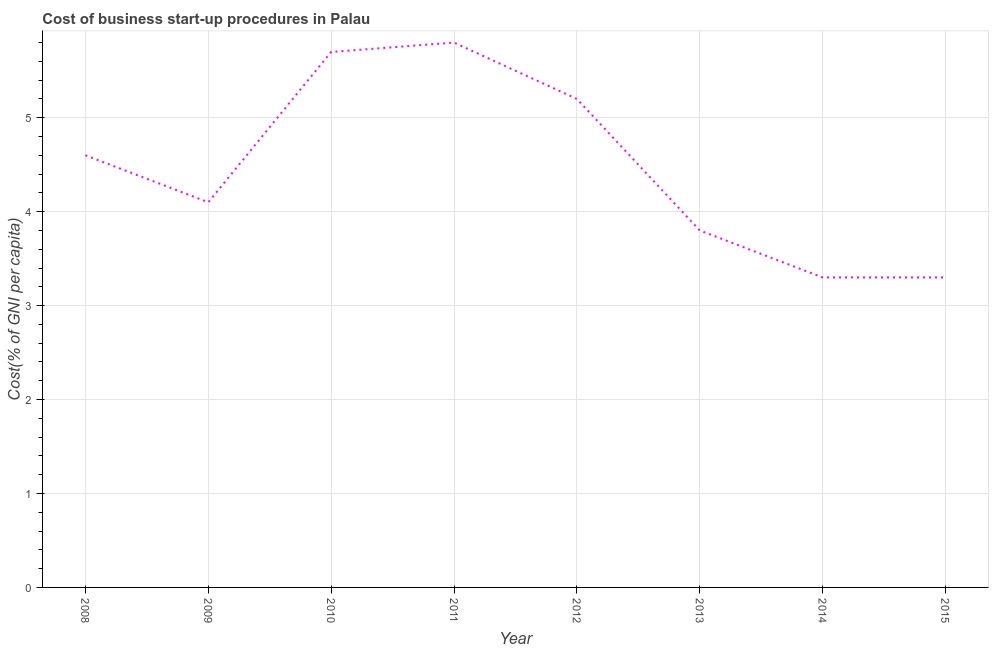In which year was the cost of business startup procedures minimum?
Ensure brevity in your answer.  2014. What is the sum of the cost of business startup procedures?
Keep it short and to the point. 35.8. What is the difference between the cost of business startup procedures in 2008 and 2014?
Make the answer very short. 1.3. What is the average cost of business startup procedures per year?
Your response must be concise. 4.47. What is the median cost of business startup procedures?
Your answer should be compact. 4.35. In how many years, is the cost of business startup procedures greater than 2 %?
Make the answer very short. 8. Do a majority of the years between 2013 and 2009 (inclusive) have cost of business startup procedures greater than 5.6 %?
Your answer should be very brief. Yes. What is the ratio of the cost of business startup procedures in 2008 to that in 2012?
Ensure brevity in your answer.  0.88. Is the cost of business startup procedures in 2009 less than that in 2012?
Ensure brevity in your answer.  Yes. Is the difference between the cost of business startup procedures in 2011 and 2015 greater than the difference between any two years?
Offer a terse response. Yes. What is the difference between the highest and the second highest cost of business startup procedures?
Give a very brief answer. 0.1. Is the sum of the cost of business startup procedures in 2012 and 2015 greater than the maximum cost of business startup procedures across all years?
Your answer should be compact. Yes. In how many years, is the cost of business startup procedures greater than the average cost of business startup procedures taken over all years?
Make the answer very short. 4. How many lines are there?
Your answer should be compact. 1. What is the title of the graph?
Offer a terse response. Cost of business start-up procedures in Palau. What is the label or title of the Y-axis?
Your response must be concise. Cost(% of GNI per capita). What is the Cost(% of GNI per capita) of 2008?
Ensure brevity in your answer.  4.6. What is the Cost(% of GNI per capita) of 2012?
Your answer should be compact. 5.2. What is the difference between the Cost(% of GNI per capita) in 2008 and 2010?
Your answer should be very brief. -1.1. What is the difference between the Cost(% of GNI per capita) in 2008 and 2011?
Your answer should be compact. -1.2. What is the difference between the Cost(% of GNI per capita) in 2008 and 2012?
Keep it short and to the point. -0.6. What is the difference between the Cost(% of GNI per capita) in 2008 and 2015?
Provide a succinct answer. 1.3. What is the difference between the Cost(% of GNI per capita) in 2009 and 2010?
Provide a succinct answer. -1.6. What is the difference between the Cost(% of GNI per capita) in 2009 and 2011?
Keep it short and to the point. -1.7. What is the difference between the Cost(% of GNI per capita) in 2009 and 2015?
Your answer should be compact. 0.8. What is the difference between the Cost(% of GNI per capita) in 2010 and 2014?
Offer a very short reply. 2.4. What is the difference between the Cost(% of GNI per capita) in 2011 and 2012?
Offer a very short reply. 0.6. What is the difference between the Cost(% of GNI per capita) in 2011 and 2013?
Provide a succinct answer. 2. What is the difference between the Cost(% of GNI per capita) in 2011 and 2014?
Provide a succinct answer. 2.5. What is the difference between the Cost(% of GNI per capita) in 2011 and 2015?
Offer a very short reply. 2.5. What is the difference between the Cost(% of GNI per capita) in 2012 and 2015?
Provide a succinct answer. 1.9. What is the difference between the Cost(% of GNI per capita) in 2013 and 2014?
Your answer should be compact. 0.5. What is the difference between the Cost(% of GNI per capita) in 2013 and 2015?
Offer a very short reply. 0.5. What is the ratio of the Cost(% of GNI per capita) in 2008 to that in 2009?
Provide a short and direct response. 1.12. What is the ratio of the Cost(% of GNI per capita) in 2008 to that in 2010?
Give a very brief answer. 0.81. What is the ratio of the Cost(% of GNI per capita) in 2008 to that in 2011?
Provide a succinct answer. 0.79. What is the ratio of the Cost(% of GNI per capita) in 2008 to that in 2012?
Offer a terse response. 0.89. What is the ratio of the Cost(% of GNI per capita) in 2008 to that in 2013?
Keep it short and to the point. 1.21. What is the ratio of the Cost(% of GNI per capita) in 2008 to that in 2014?
Make the answer very short. 1.39. What is the ratio of the Cost(% of GNI per capita) in 2008 to that in 2015?
Ensure brevity in your answer.  1.39. What is the ratio of the Cost(% of GNI per capita) in 2009 to that in 2010?
Give a very brief answer. 0.72. What is the ratio of the Cost(% of GNI per capita) in 2009 to that in 2011?
Provide a succinct answer. 0.71. What is the ratio of the Cost(% of GNI per capita) in 2009 to that in 2012?
Make the answer very short. 0.79. What is the ratio of the Cost(% of GNI per capita) in 2009 to that in 2013?
Offer a very short reply. 1.08. What is the ratio of the Cost(% of GNI per capita) in 2009 to that in 2014?
Your answer should be compact. 1.24. What is the ratio of the Cost(% of GNI per capita) in 2009 to that in 2015?
Provide a succinct answer. 1.24. What is the ratio of the Cost(% of GNI per capita) in 2010 to that in 2012?
Ensure brevity in your answer.  1.1. What is the ratio of the Cost(% of GNI per capita) in 2010 to that in 2014?
Provide a short and direct response. 1.73. What is the ratio of the Cost(% of GNI per capita) in 2010 to that in 2015?
Make the answer very short. 1.73. What is the ratio of the Cost(% of GNI per capita) in 2011 to that in 2012?
Provide a short and direct response. 1.11. What is the ratio of the Cost(% of GNI per capita) in 2011 to that in 2013?
Keep it short and to the point. 1.53. What is the ratio of the Cost(% of GNI per capita) in 2011 to that in 2014?
Provide a succinct answer. 1.76. What is the ratio of the Cost(% of GNI per capita) in 2011 to that in 2015?
Offer a very short reply. 1.76. What is the ratio of the Cost(% of GNI per capita) in 2012 to that in 2013?
Your response must be concise. 1.37. What is the ratio of the Cost(% of GNI per capita) in 2012 to that in 2014?
Offer a very short reply. 1.58. What is the ratio of the Cost(% of GNI per capita) in 2012 to that in 2015?
Offer a terse response. 1.58. What is the ratio of the Cost(% of GNI per capita) in 2013 to that in 2014?
Provide a succinct answer. 1.15. What is the ratio of the Cost(% of GNI per capita) in 2013 to that in 2015?
Offer a terse response. 1.15. 